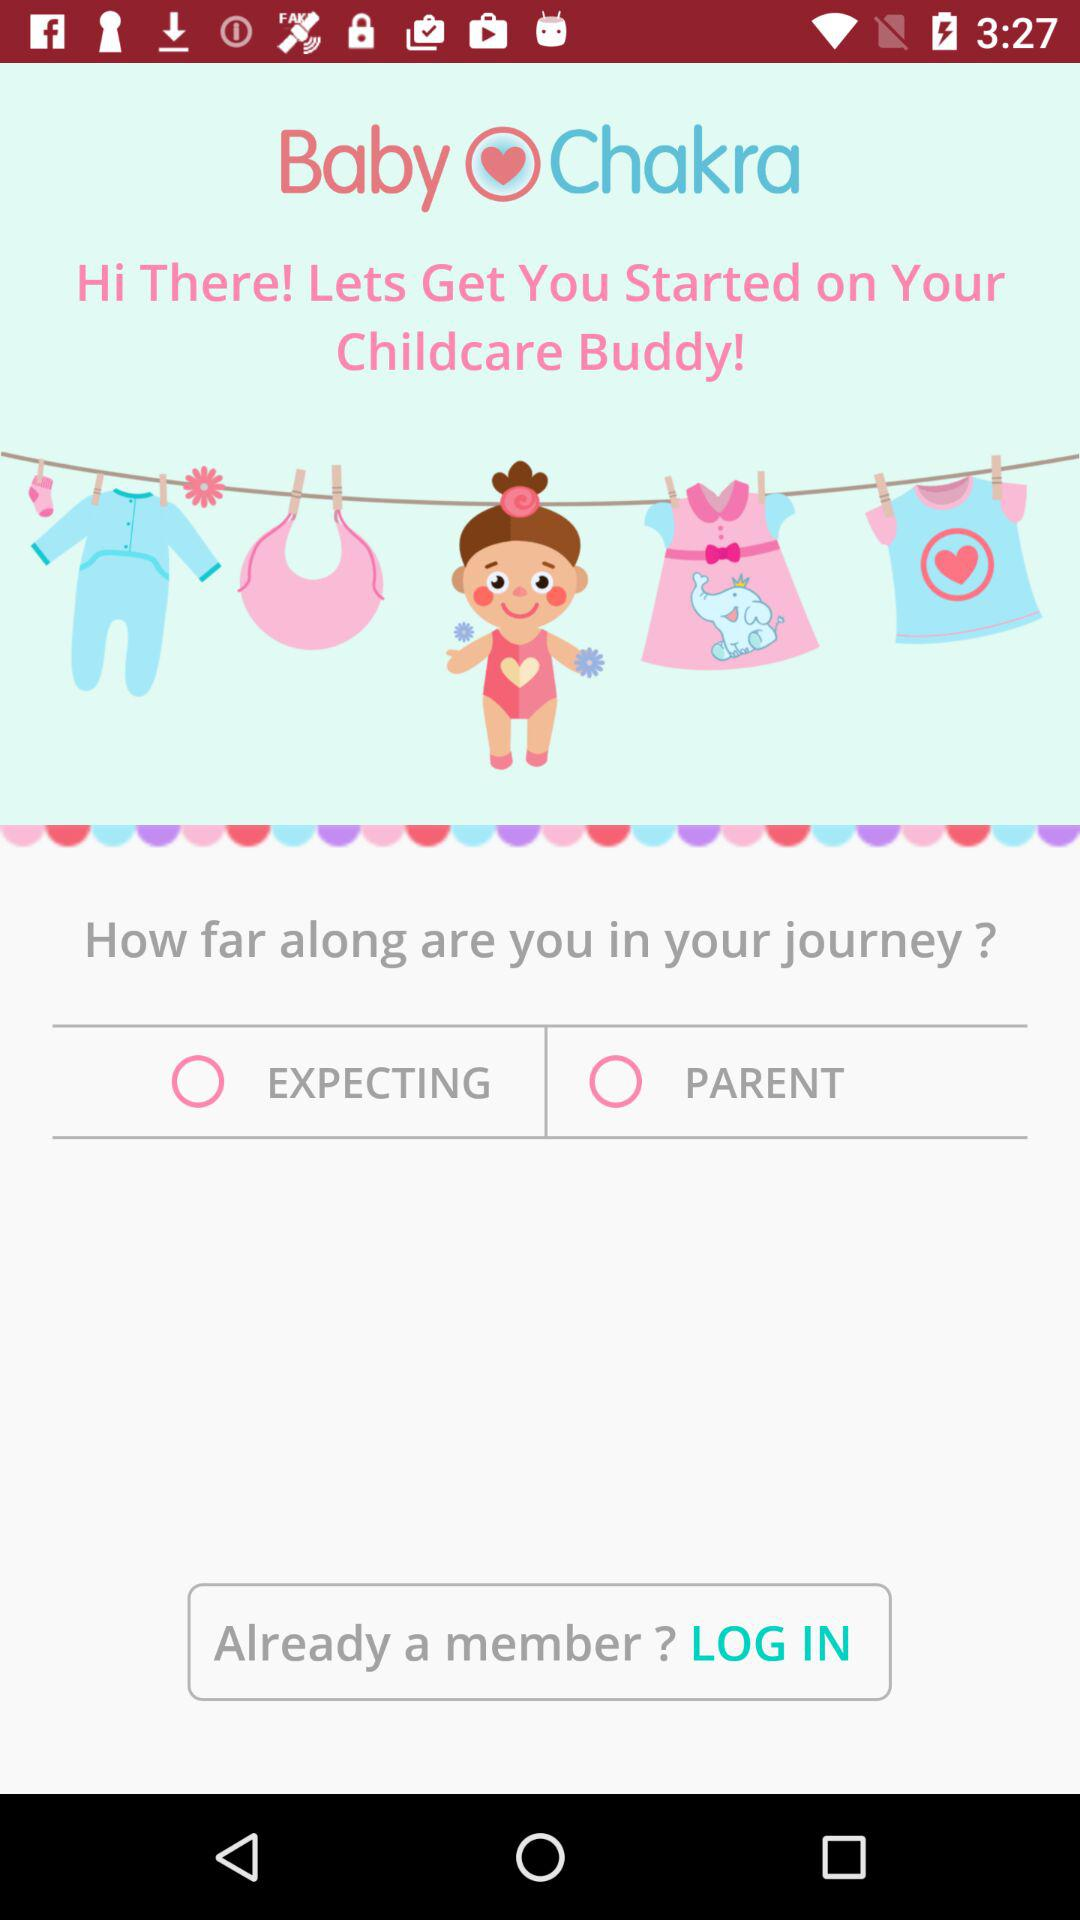Is there any choice picked or not?
When the provided information is insufficient, respond with <no answer>. <no answer> 